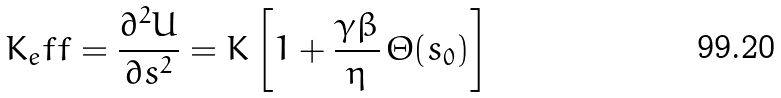Convert formula to latex. <formula><loc_0><loc_0><loc_500><loc_500>K _ { e } f f = \frac { \partial ^ { 2 } U } { \partial s ^ { 2 } } = K \left [ 1 + \frac { \gamma \beta } { \eta } \, \Theta ( s _ { 0 } ) \right ]</formula> 